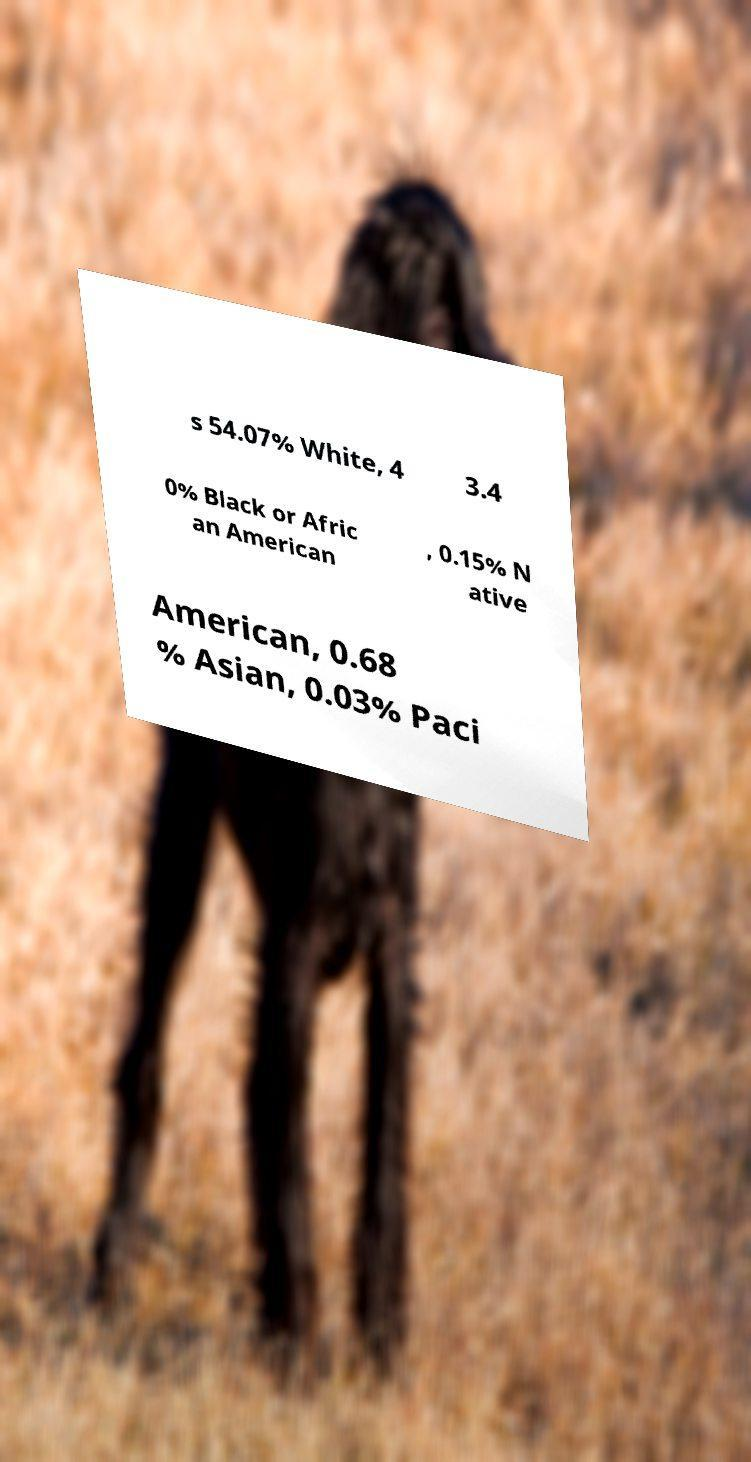Can you accurately transcribe the text from the provided image for me? s 54.07% White, 4 3.4 0% Black or Afric an American , 0.15% N ative American, 0.68 % Asian, 0.03% Paci 